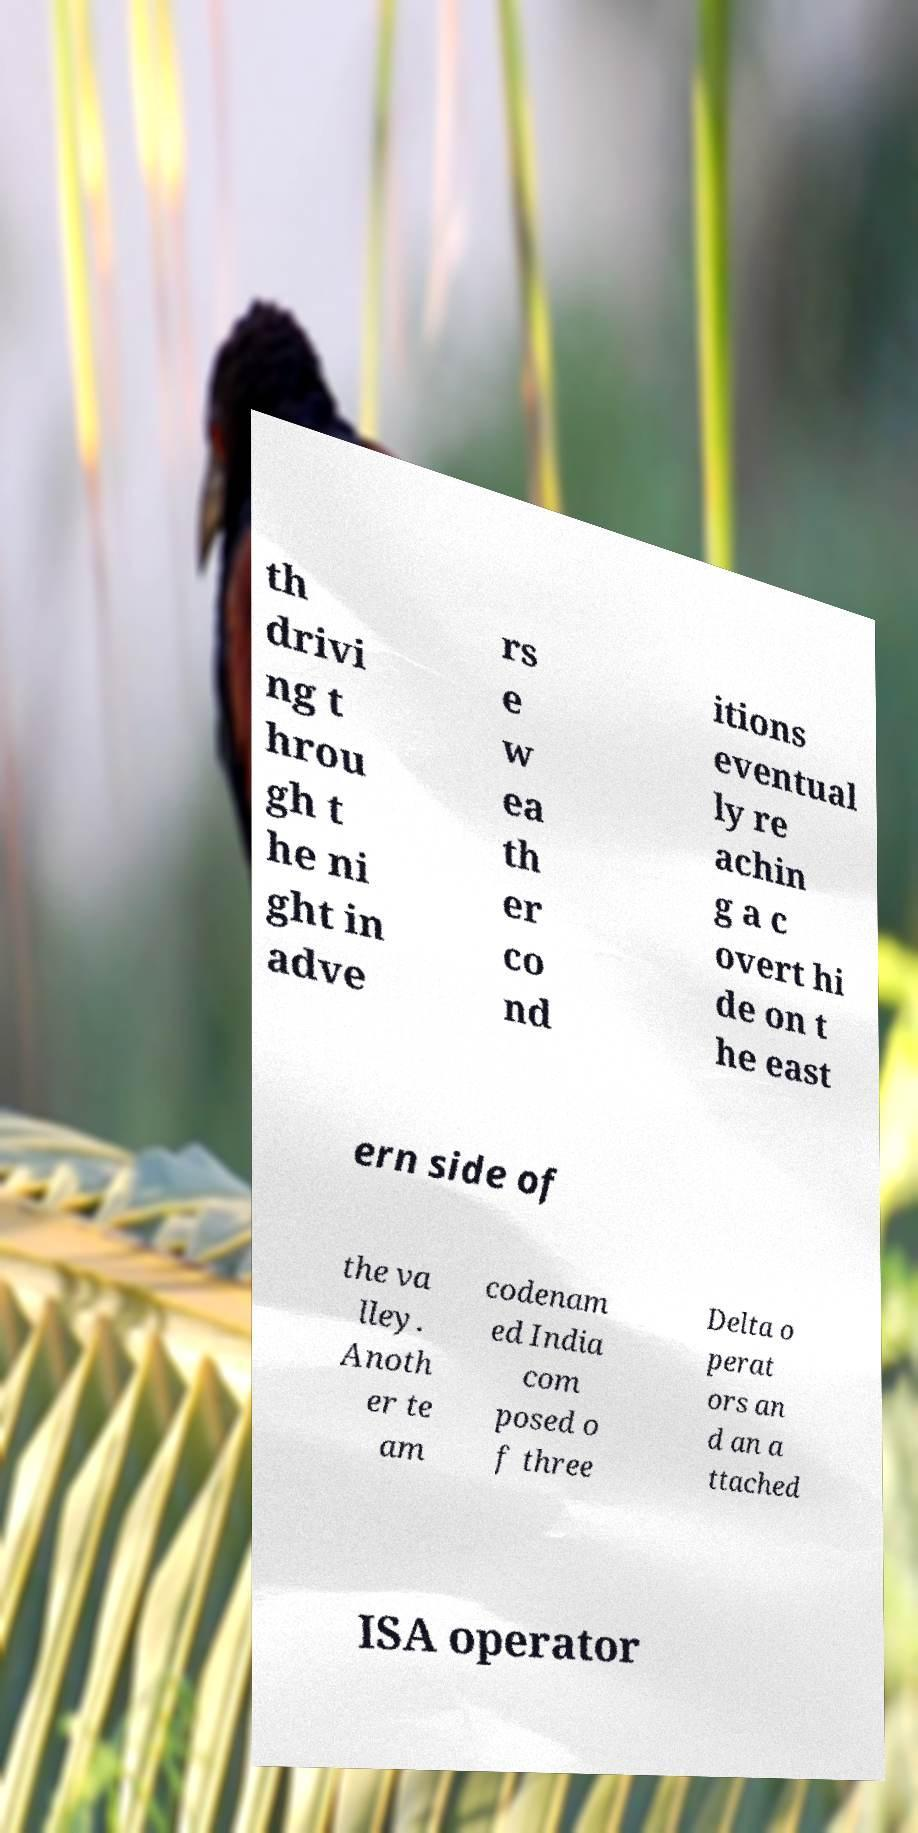Please read and relay the text visible in this image. What does it say? th drivi ng t hrou gh t he ni ght in adve rs e w ea th er co nd itions eventual ly re achin g a c overt hi de on t he east ern side of the va lley. Anoth er te am codenam ed India com posed o f three Delta o perat ors an d an a ttached ISA operator 